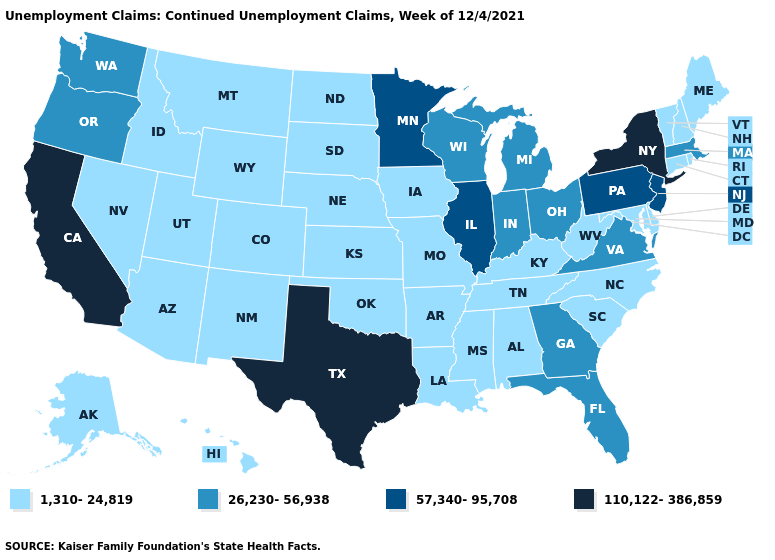Does the first symbol in the legend represent the smallest category?
Give a very brief answer. Yes. Name the states that have a value in the range 26,230-56,938?
Keep it brief. Florida, Georgia, Indiana, Massachusetts, Michigan, Ohio, Oregon, Virginia, Washington, Wisconsin. Name the states that have a value in the range 57,340-95,708?
Give a very brief answer. Illinois, Minnesota, New Jersey, Pennsylvania. Does the first symbol in the legend represent the smallest category?
Keep it brief. Yes. Does the first symbol in the legend represent the smallest category?
Quick response, please. Yes. Does Wisconsin have a higher value than Florida?
Concise answer only. No. Does Iowa have the highest value in the MidWest?
Be succinct. No. Among the states that border Pennsylvania , which have the lowest value?
Quick response, please. Delaware, Maryland, West Virginia. Name the states that have a value in the range 1,310-24,819?
Give a very brief answer. Alabama, Alaska, Arizona, Arkansas, Colorado, Connecticut, Delaware, Hawaii, Idaho, Iowa, Kansas, Kentucky, Louisiana, Maine, Maryland, Mississippi, Missouri, Montana, Nebraska, Nevada, New Hampshire, New Mexico, North Carolina, North Dakota, Oklahoma, Rhode Island, South Carolina, South Dakota, Tennessee, Utah, Vermont, West Virginia, Wyoming. Among the states that border Delaware , does New Jersey have the lowest value?
Write a very short answer. No. What is the value of New Hampshire?
Write a very short answer. 1,310-24,819. Does Delaware have the same value as West Virginia?
Give a very brief answer. Yes. Does New Hampshire have the highest value in the USA?
Answer briefly. No. What is the highest value in states that border Vermont?
Be succinct. 110,122-386,859. Does South Dakota have the same value as California?
Write a very short answer. No. 